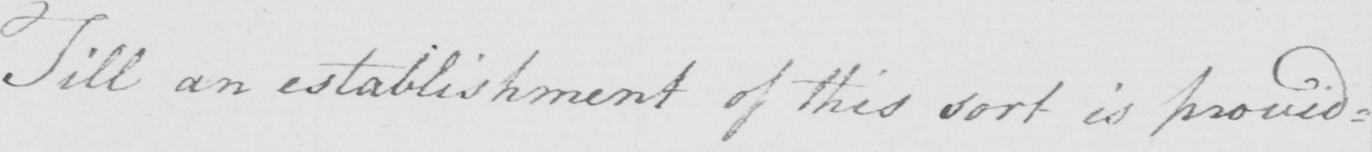Please transcribe the handwritten text in this image. Till an establishment of the sort is provid= 